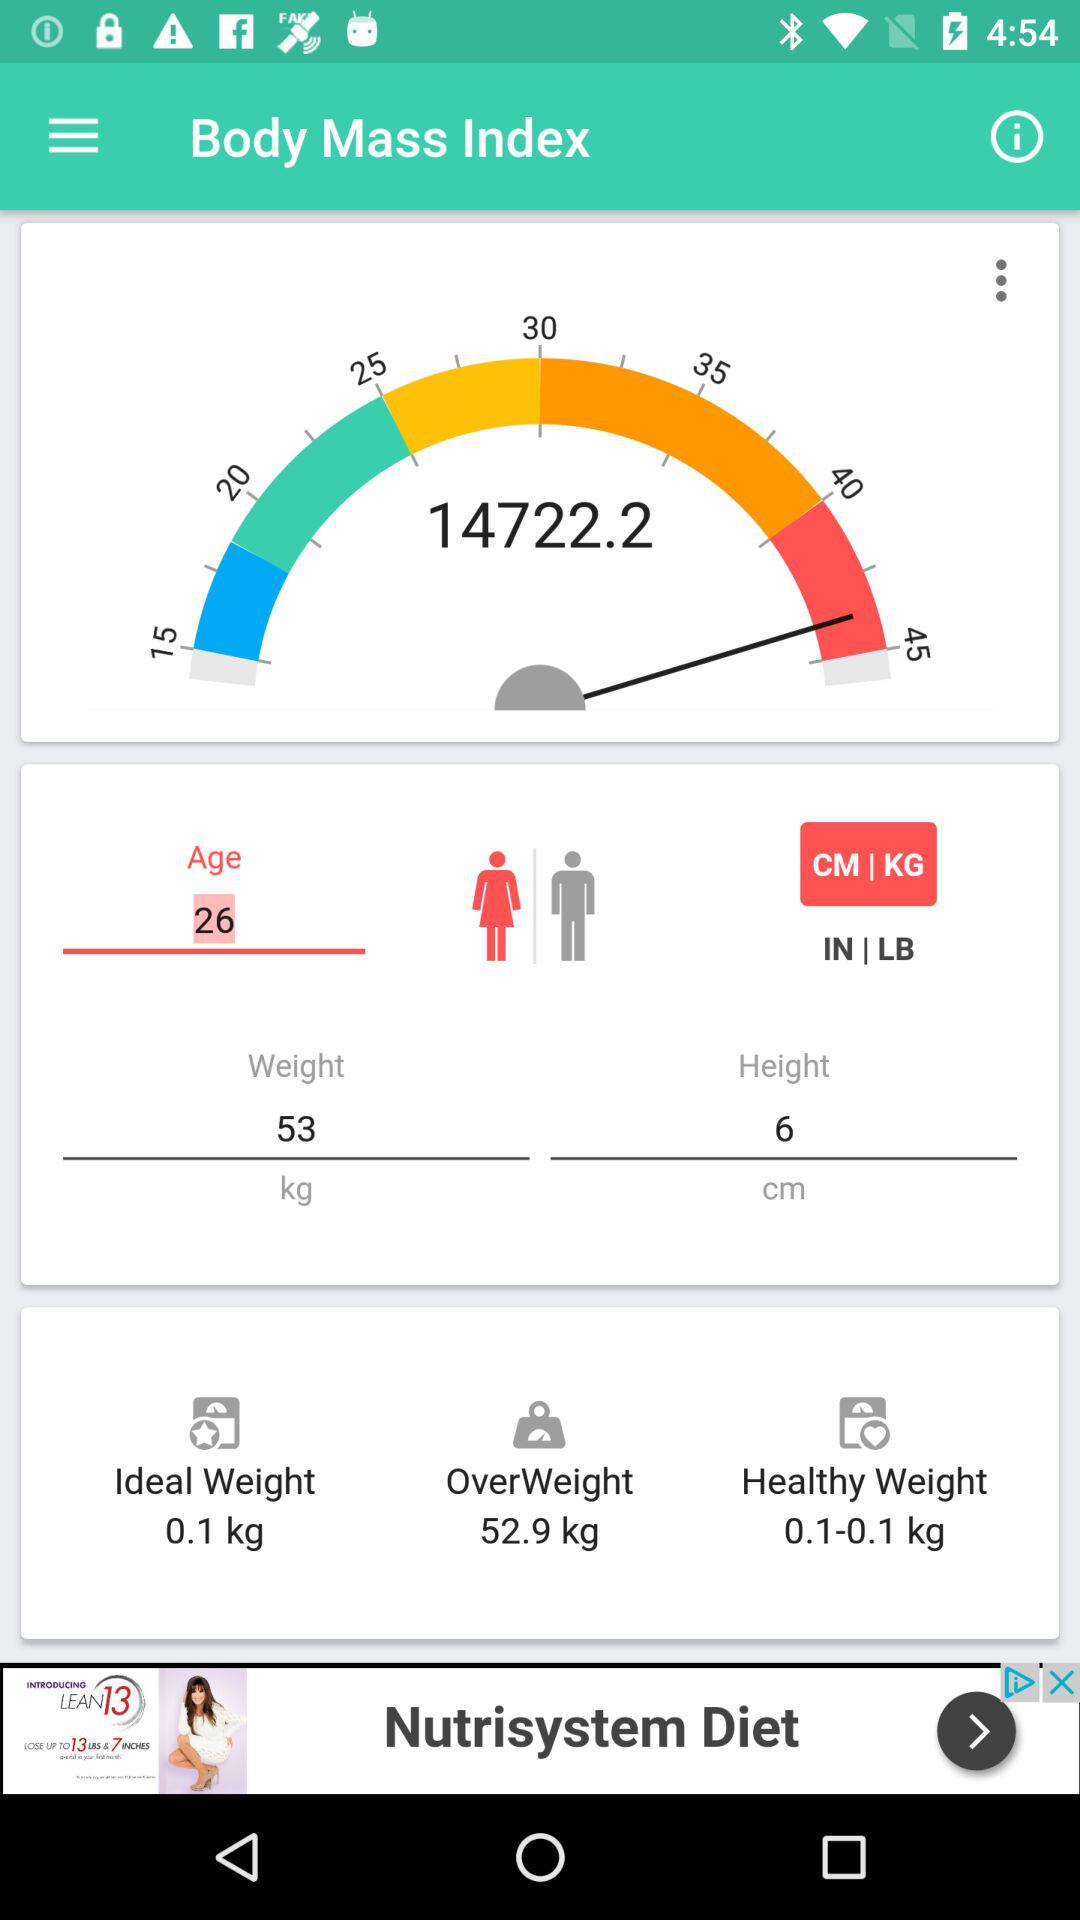What is the ideal weight? The ideal weight is 0.1 kg. 